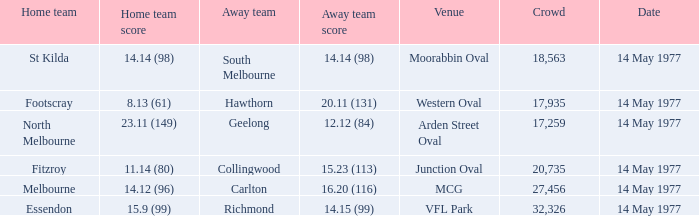Name the away team for essendon Richmond. 